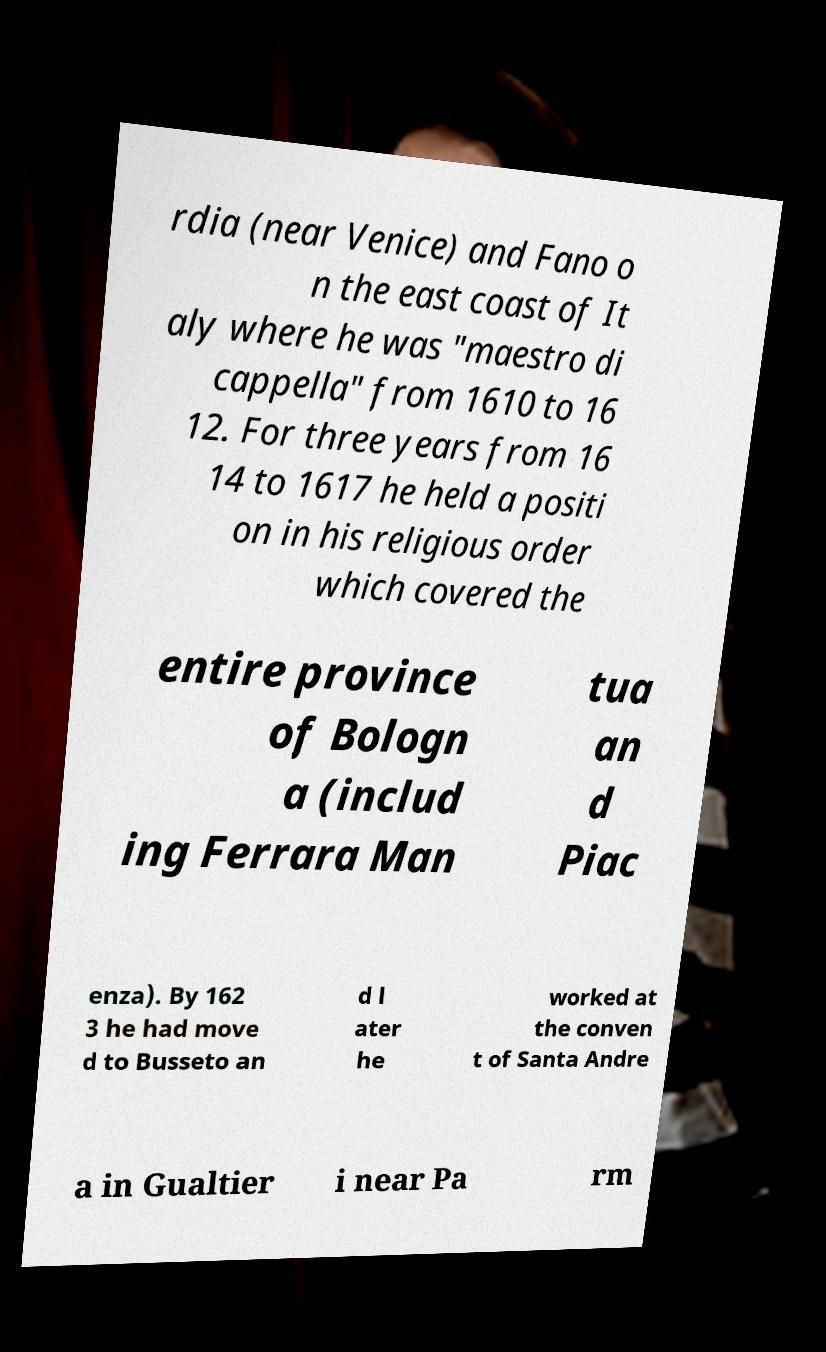Please identify and transcribe the text found in this image. rdia (near Venice) and Fano o n the east coast of It aly where he was "maestro di cappella" from 1610 to 16 12. For three years from 16 14 to 1617 he held a positi on in his religious order which covered the entire province of Bologn a (includ ing Ferrara Man tua an d Piac enza). By 162 3 he had move d to Busseto an d l ater he worked at the conven t of Santa Andre a in Gualtier i near Pa rm 